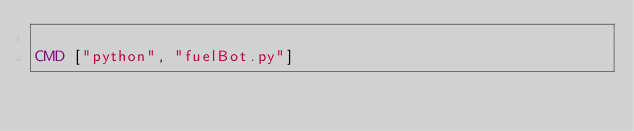Convert code to text. <code><loc_0><loc_0><loc_500><loc_500><_Dockerfile_>
CMD ["python", "fuelBot.py"]
</code> 